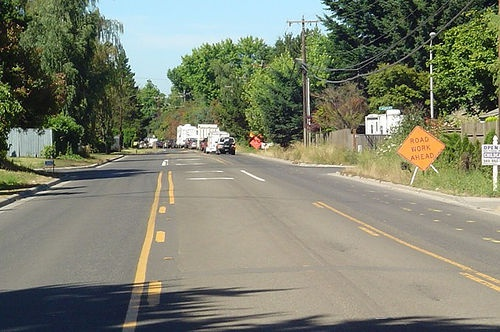Describe the objects in this image and their specific colors. I can see truck in darkgreen, white, black, gray, and darkgray tones, car in darkgreen, black, gray, lightgray, and darkgray tones, truck in darkgreen, ivory, darkgray, lightgray, and gray tones, car in darkgreen, darkgray, gray, and lightgray tones, and car in darkgreen, gray, black, and maroon tones in this image. 